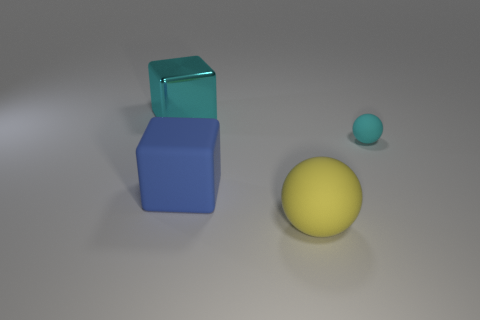Add 4 red shiny objects. How many objects exist? 8 Subtract 0 brown spheres. How many objects are left? 4 Subtract all yellow balls. Subtract all big yellow matte balls. How many objects are left? 2 Add 2 blue objects. How many blue objects are left? 3 Add 2 small spheres. How many small spheres exist? 3 